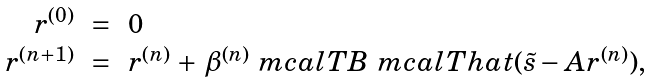<formula> <loc_0><loc_0><loc_500><loc_500>\begin{array} { r c l } r ^ { ( 0 ) } & = & 0 \\ r ^ { ( n + 1 ) } & = & r ^ { ( n ) } \, + \, \beta ^ { ( n ) } \ m c a l T B \ m c a l T h a t ( \tilde { s } - A r ^ { ( n ) } ) , \end{array}</formula> 